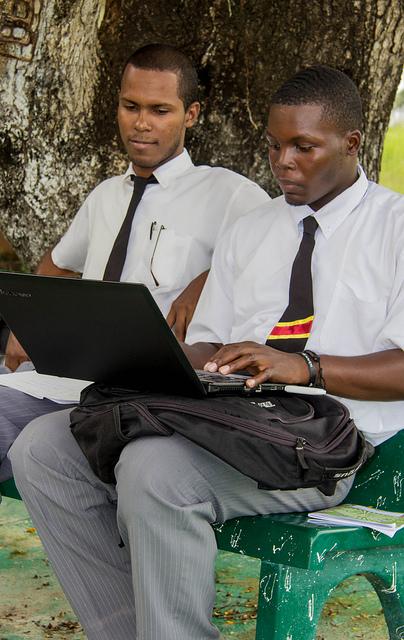Are these two people lovers?
Answer briefly. No. Are these men clean shaven?
Concise answer only. Yes. Are these men, business men?
Be succinct. Yes. What color stripes are on his tie?
Concise answer only. Red and yellow. 